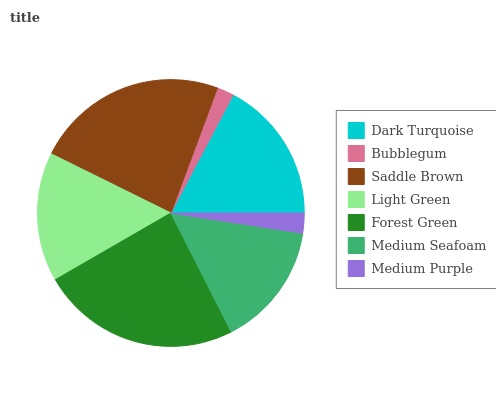Is Bubblegum the minimum?
Answer yes or no. Yes. Is Forest Green the maximum?
Answer yes or no. Yes. Is Saddle Brown the minimum?
Answer yes or no. No. Is Saddle Brown the maximum?
Answer yes or no. No. Is Saddle Brown greater than Bubblegum?
Answer yes or no. Yes. Is Bubblegum less than Saddle Brown?
Answer yes or no. Yes. Is Bubblegum greater than Saddle Brown?
Answer yes or no. No. Is Saddle Brown less than Bubblegum?
Answer yes or no. No. Is Light Green the high median?
Answer yes or no. Yes. Is Light Green the low median?
Answer yes or no. Yes. Is Bubblegum the high median?
Answer yes or no. No. Is Medium Purple the low median?
Answer yes or no. No. 